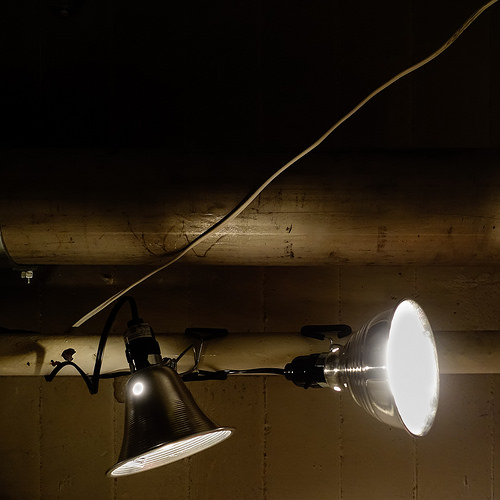<image>
Is the light on the pole? Yes. Looking at the image, I can see the light is positioned on top of the pole, with the pole providing support. 